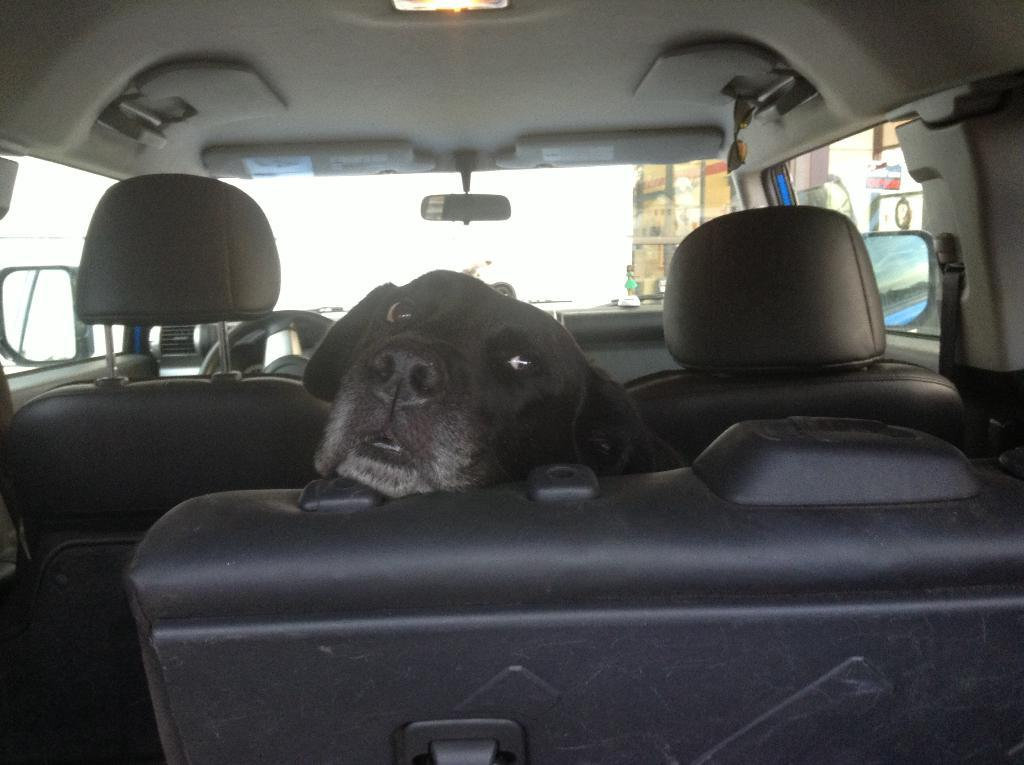What type of animal is in the car in the image? There is a black dog in the car. What can be seen in the background of the image? A side mirror, a steering wheel, an AC vent, and car seats are visible in the background. Can you describe the car's interior features? The car has a steering wheel, an AC vent, and car seats. How much salt is on the dog's fur in the image? There is no salt visible on the dog's fur in the image. What type of beam is supporting the car in the image? The image does not show any beams supporting the car; it is a regular car on the ground. 